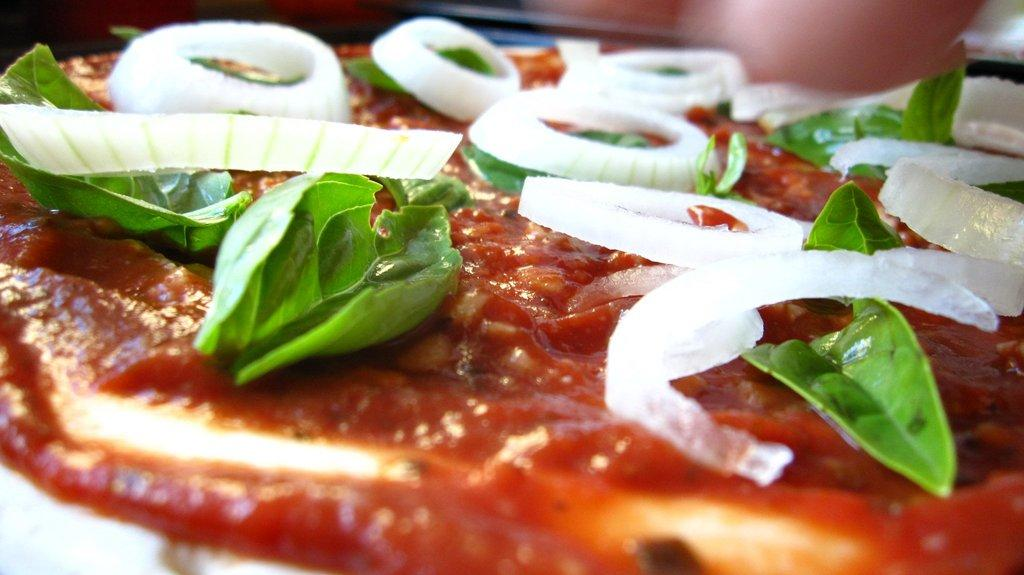What type of food can be seen in the picture? There are eatable items in the picture. How are the eatable items prepared or served? There is a sauce spread on the eatable items. What additional ingredients are present on the eatable items? There are leaves and onion slices on the eatable items. How many nuts are visible on the eatable items in the image? There is no mention of nuts in the provided facts, so we cannot determine the number of nuts in the image. 